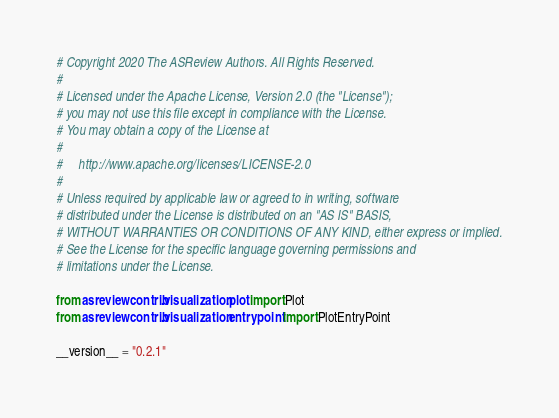<code> <loc_0><loc_0><loc_500><loc_500><_Python_># Copyright 2020 The ASReview Authors. All Rights Reserved.
#
# Licensed under the Apache License, Version 2.0 (the "License");
# you may not use this file except in compliance with the License.
# You may obtain a copy of the License at
#
#     http://www.apache.org/licenses/LICENSE-2.0
#
# Unless required by applicable law or agreed to in writing, software
# distributed under the License is distributed on an "AS IS" BASIS,
# WITHOUT WARRANTIES OR CONDITIONS OF ANY KIND, either express or implied.
# See the License for the specific language governing permissions and
# limitations under the License.

from asreviewcontrib.visualization.plot import Plot
from asreviewcontrib.visualization.entrypoint import PlotEntryPoint

__version__ = "0.2.1"
</code> 